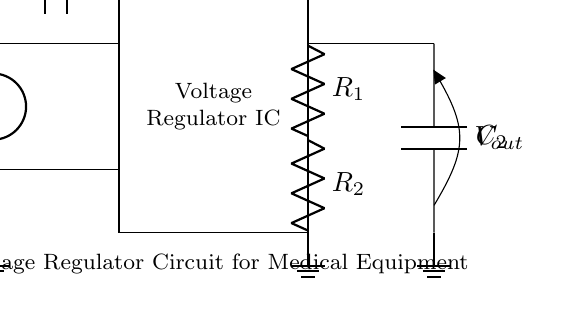What is the input component in this circuit? The input component is the voltage source labeled as V_in, which provides the electrical energy required for the circuit to function.
Answer: V_in What is the role of the capacitor labeled C1? Capacitor C1 smooths out voltage fluctuations and helps stabilize the input voltage to the voltage regulator, preventing sharp drops or spikes from damaging components.
Answer: Smooths input voltage How many resistors are in the circuit? The circuit contains two resistors labeled as R_1 and R_2, which are used in the regulation process to divide the voltage and set the output level.
Answer: Two What is the output voltage component labeled as? The output voltage is labeled as V_out, which represents the stable voltage provided to the medical equipment from the voltage regulator circuit.
Answer: V_out Which component is responsible for regulating the output voltage? The voltage regulator IC is responsible for maintaining a stable output voltage despite variations in input voltage or load conditions.
Answer: Voltage Regulator IC What is the purpose of the capacitor labeled C2? Capacitor C2 enhances the stability of the output voltage by filtering out noise and providing charge storage to handle transient loads efficiently.
Answer: Filters output voltage 